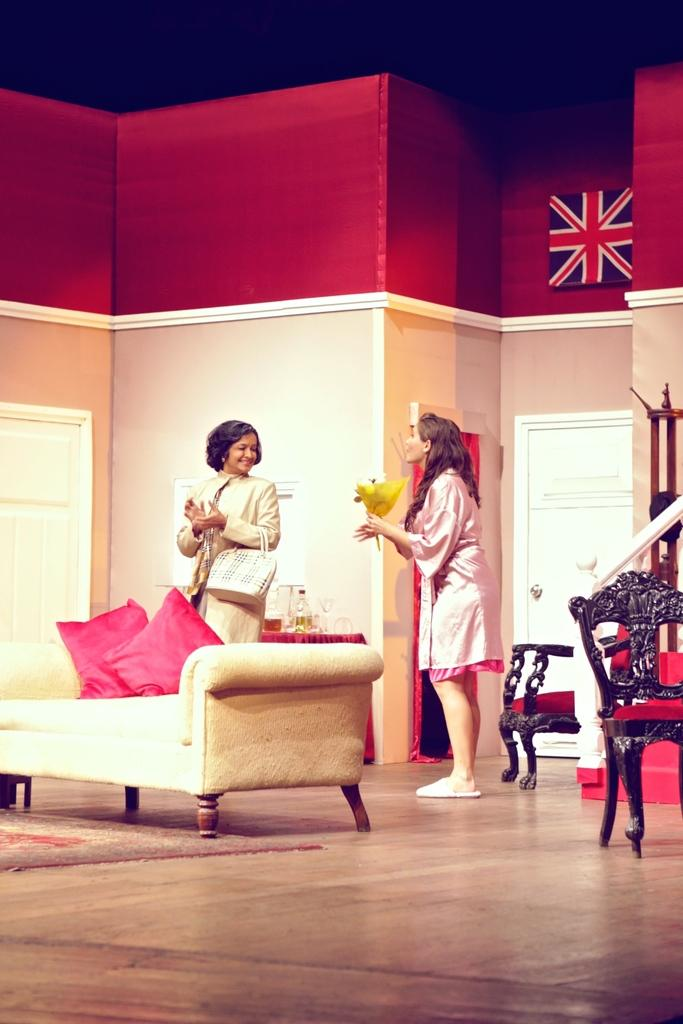How many women are in the image? There are 2 women standing and smiling in the image. What furniture is present in the room? There are chairs and tables in the room. What type of soft furnishings can be seen in the room? There are pillows in the room. What decorative item is present in the room? There is a flag in the room. How many doors are in the room? There are 2 doors in the room. What type of yarn is being used to create the industry depicted in the image? There is no industry or yarn present in the image; it features 2 women standing and smiling, along with furniture and decorative items in a room. 